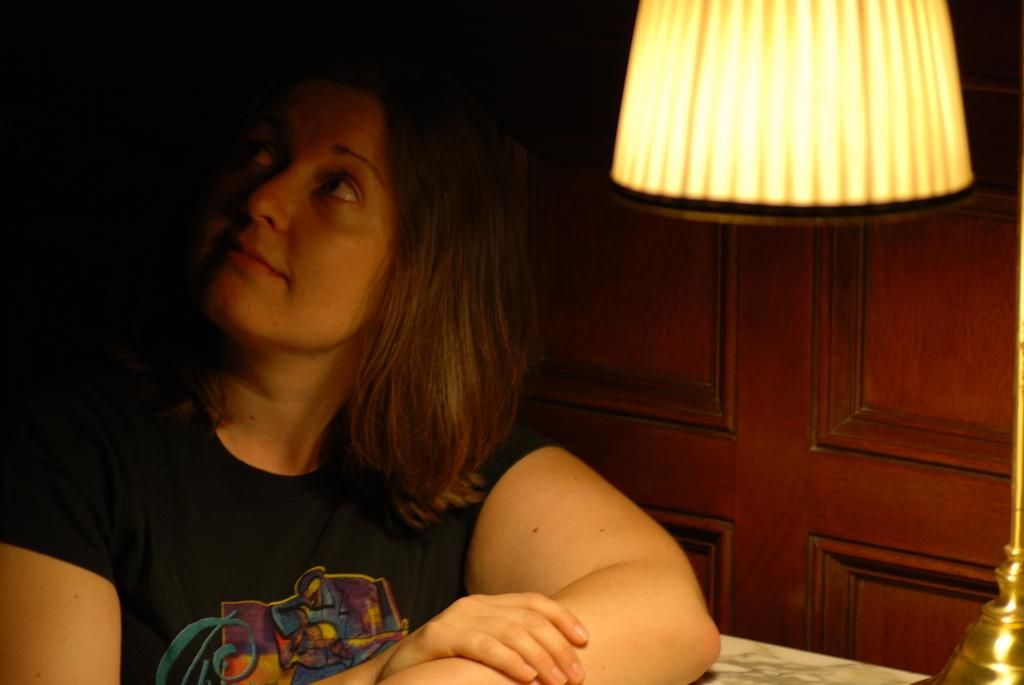Who is present in the image? There is a woman in the image. What is the woman wearing? The woman is wearing a black t-shirt. What object can be seen in the image besides the woman? There is a lamp in the image. What is the color of the background in the image? The background of the image is dark. What type of waste can be seen in the image? There is no waste present in the image. What tool is the woman using to fix the lamp in the image? The image does not show the woman using any tools, nor does it depict her fixing the lamp. 